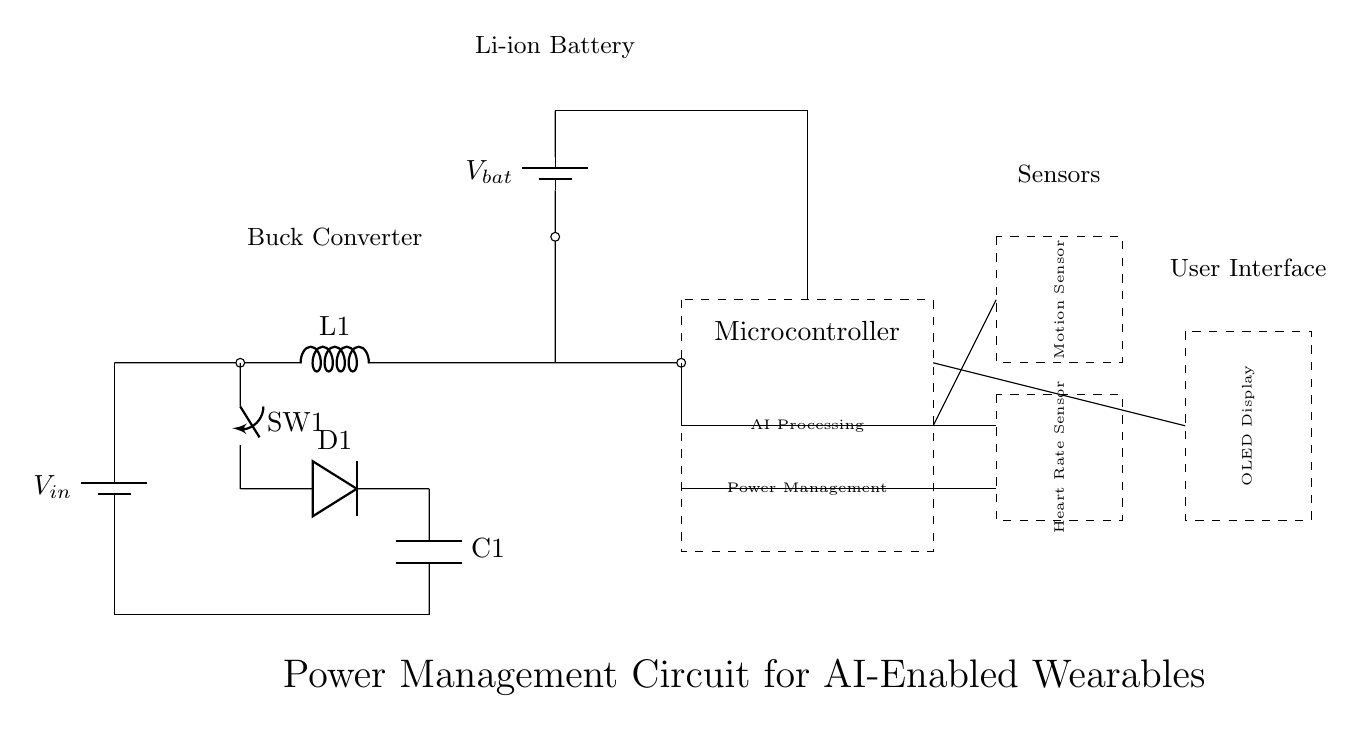What is the power source in this circuit? The power source is labeled as V_in, which refers to the input voltage supplied to the circuit. It is indicated as a battery symbol at the top left of the circuit diagram.
Answer: V_in What type of converter is used in this circuit? The converter is labeled as a buck converter, which steps down the voltage for the components. This is visible in the diagram where the inductor (L1), diode (D1), and capacitor (C1) are present in the configuration typically used for buck conversion.
Answer: Buck Converter How many sensors are included in the circuit? There are two sensors indicated in the circuit: a motion sensor and a heart rate sensor, both represented in dashed rectangles. Each sensor has its own label, clearly identifying them.
Answer: Two What is the purpose of the components labeled as D1 and C1? D1 is a diode used to allow current to flow in one direction in the buck converter, preventing backflow. C1 is a capacitor used to smooth the voltage output by storing energy and releasing it when needed. This functionality is crucial in power management situations.
Answer: Diode and Capacitor What voltage does the battery provide? The battery (V_bat) is connected to the circuit, but the specific voltage value is not provided in the diagram. However, it typically represents the stored voltage of a Li-ion battery, which is usually around 3.7 volts.
Answer: V_bat Which component is responsible for AI processing? The microcontroller is responsible for AI processing, as indicated by the label inside the dashed rectangle, where it states "AI Processing" along with "Power Management" showing its dual function.
Answer: Microcontroller What role does the switch SW1 play in the circuit? SW1 is a switch that allows for control over the flow of current in the circuit by either opening or closing the circuit path. Its position determines whether the buck converter is active, thereby enabling or disabling the voltage conversion process.
Answer: Control current flow 